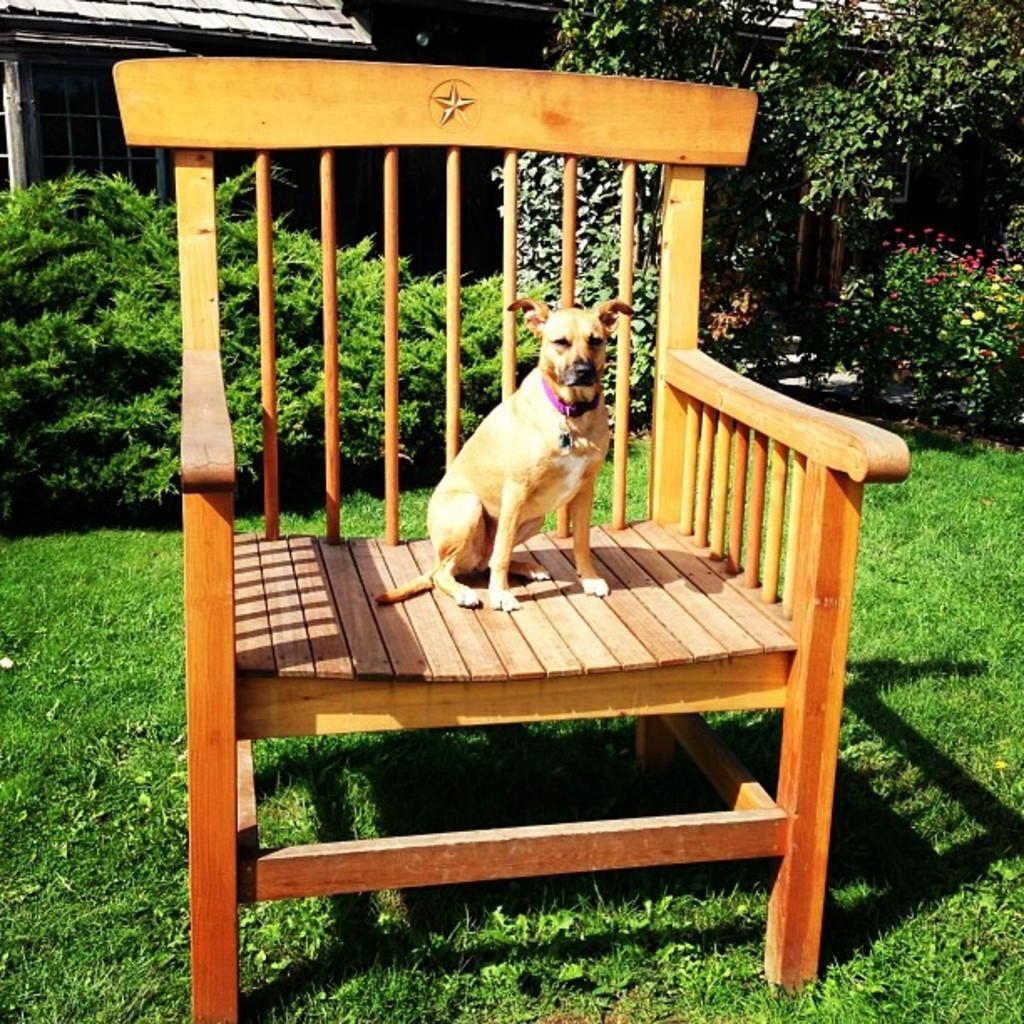What type of animal is in the image? There is a dog in the image. Where is the dog located? The dog is on a chair. What is the chair placed on? The chair is on grass. What can be seen in the background of the image? There are trees in the background of the image. How is the steam being distributed in the image? There is no steam present in the image. 